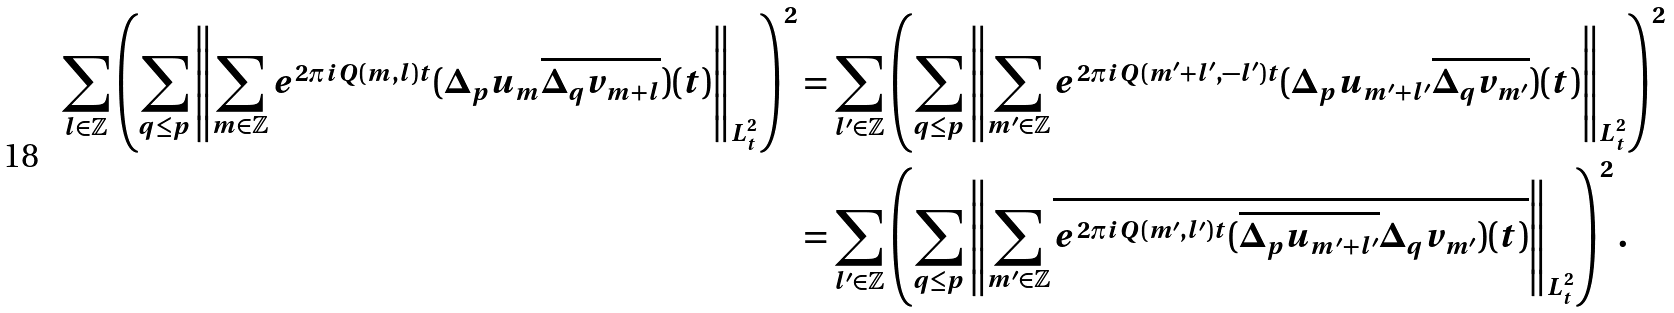Convert formula to latex. <formula><loc_0><loc_0><loc_500><loc_500>\sum _ { l \in \mathbb { Z } } \left ( \sum _ { q \leq p } \left \| \sum _ { m \in \mathbb { Z } } e ^ { 2 \pi i Q ( m , l ) t } ( \Delta _ { p } u _ { m } \overline { \Delta _ { q } v _ { m + l } } ) ( t ) \right \| _ { L _ { t } ^ { 2 } } \right ) ^ { 2 } & = \sum _ { l ^ { \prime } \in \mathbb { Z } } \left ( \sum _ { q \leq p } \left \| \sum _ { m ^ { \prime } \in \mathbb { Z } } e ^ { 2 \pi i Q ( m ^ { \prime } + l ^ { \prime } , - l ^ { \prime } ) t } ( \Delta _ { p } u _ { m ^ { \prime } + l ^ { \prime } } \overline { \Delta _ { q } v _ { m ^ { \prime } } } ) ( t ) \right \| _ { L _ { t } ^ { 2 } } \right ) ^ { 2 } \\ & = \sum _ { l ^ { \prime } \in \mathbb { Z } } \left ( \sum _ { q \leq p } \left \| \sum _ { m ^ { \prime } \in \mathbb { Z } } \overline { e ^ { 2 \pi i Q ( m ^ { \prime } , l ^ { \prime } ) t } ( \overline { \Delta _ { p } u _ { m ^ { \prime } + l ^ { \prime } } } \Delta _ { q } v _ { m ^ { \prime } } ) ( t ) } \right \| _ { L _ { t } ^ { 2 } } \right ) ^ { 2 } .</formula> 